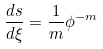Convert formula to latex. <formula><loc_0><loc_0><loc_500><loc_500>\frac { d s } { d \xi } = \frac { 1 } { m } \phi ^ { - m }</formula> 